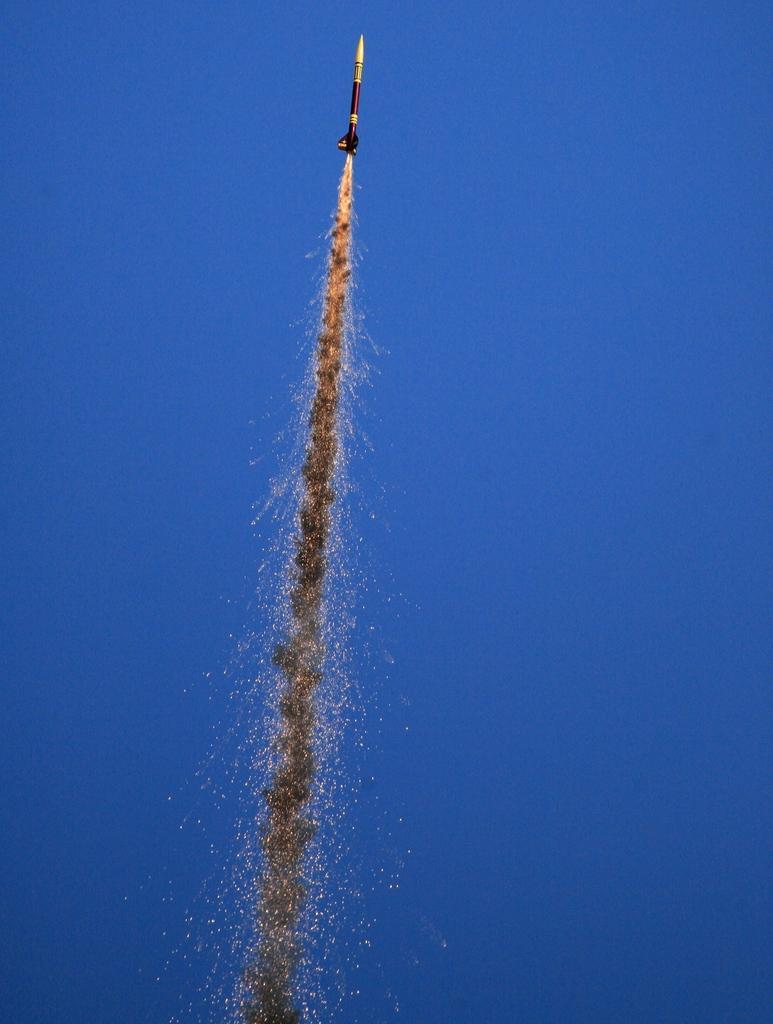In one or two sentences, can you explain what this image depicts? In this image we can see a rocket with fire and the sky in the background. 